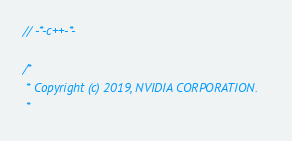Convert code to text. <code><loc_0><loc_0><loc_500><loc_500><_Cuda_>// -*-c++-*-

/*
 * Copyright (c) 2019, NVIDIA CORPORATION.
 *</code> 